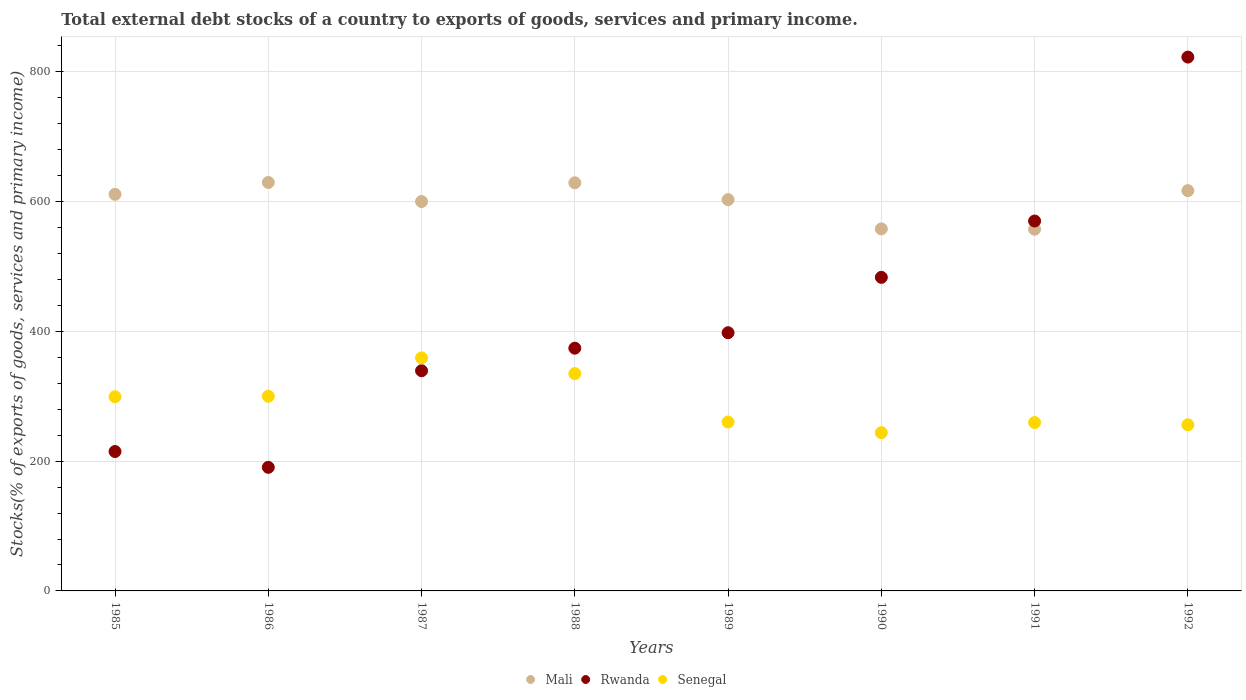How many different coloured dotlines are there?
Give a very brief answer. 3. Is the number of dotlines equal to the number of legend labels?
Provide a short and direct response. Yes. What is the total debt stocks in Senegal in 1985?
Your answer should be very brief. 299.27. Across all years, what is the maximum total debt stocks in Rwanda?
Your answer should be very brief. 822.66. Across all years, what is the minimum total debt stocks in Rwanda?
Ensure brevity in your answer.  190.46. In which year was the total debt stocks in Rwanda maximum?
Your answer should be very brief. 1992. What is the total total debt stocks in Rwanda in the graph?
Provide a short and direct response. 3392.5. What is the difference between the total debt stocks in Mali in 1985 and that in 1988?
Make the answer very short. -17.75. What is the difference between the total debt stocks in Rwanda in 1988 and the total debt stocks in Senegal in 1987?
Your answer should be compact. 14.99. What is the average total debt stocks in Rwanda per year?
Keep it short and to the point. 424.06. In the year 1985, what is the difference between the total debt stocks in Rwanda and total debt stocks in Senegal?
Ensure brevity in your answer.  -84.44. In how many years, is the total debt stocks in Mali greater than 240 %?
Make the answer very short. 8. What is the ratio of the total debt stocks in Rwanda in 1988 to that in 1990?
Your response must be concise. 0.77. Is the total debt stocks in Senegal in 1990 less than that in 1992?
Ensure brevity in your answer.  Yes. Is the difference between the total debt stocks in Rwanda in 1986 and 1987 greater than the difference between the total debt stocks in Senegal in 1986 and 1987?
Your response must be concise. No. What is the difference between the highest and the second highest total debt stocks in Senegal?
Your response must be concise. 24.15. What is the difference between the highest and the lowest total debt stocks in Rwanda?
Make the answer very short. 632.2. Is the sum of the total debt stocks in Senegal in 1990 and 1992 greater than the maximum total debt stocks in Rwanda across all years?
Offer a terse response. No. How many dotlines are there?
Your response must be concise. 3. What is the difference between two consecutive major ticks on the Y-axis?
Your answer should be compact. 200. Are the values on the major ticks of Y-axis written in scientific E-notation?
Your response must be concise. No. Does the graph contain any zero values?
Your answer should be very brief. No. Where does the legend appear in the graph?
Ensure brevity in your answer.  Bottom center. What is the title of the graph?
Offer a very short reply. Total external debt stocks of a country to exports of goods, services and primary income. What is the label or title of the Y-axis?
Your answer should be very brief. Stocks(% of exports of goods, services and primary income). What is the Stocks(% of exports of goods, services and primary income) of Mali in 1985?
Keep it short and to the point. 611.16. What is the Stocks(% of exports of goods, services and primary income) of Rwanda in 1985?
Your response must be concise. 214.83. What is the Stocks(% of exports of goods, services and primary income) in Senegal in 1985?
Your response must be concise. 299.27. What is the Stocks(% of exports of goods, services and primary income) of Mali in 1986?
Your response must be concise. 629.46. What is the Stocks(% of exports of goods, services and primary income) in Rwanda in 1986?
Your response must be concise. 190.46. What is the Stocks(% of exports of goods, services and primary income) in Senegal in 1986?
Provide a succinct answer. 300.03. What is the Stocks(% of exports of goods, services and primary income) of Mali in 1987?
Ensure brevity in your answer.  600.04. What is the Stocks(% of exports of goods, services and primary income) of Rwanda in 1987?
Your response must be concise. 339.33. What is the Stocks(% of exports of goods, services and primary income) in Senegal in 1987?
Offer a terse response. 359.08. What is the Stocks(% of exports of goods, services and primary income) in Mali in 1988?
Provide a short and direct response. 628.91. What is the Stocks(% of exports of goods, services and primary income) in Rwanda in 1988?
Offer a terse response. 374.06. What is the Stocks(% of exports of goods, services and primary income) of Senegal in 1988?
Provide a succinct answer. 334.92. What is the Stocks(% of exports of goods, services and primary income) of Mali in 1989?
Provide a succinct answer. 602.96. What is the Stocks(% of exports of goods, services and primary income) in Rwanda in 1989?
Give a very brief answer. 397.87. What is the Stocks(% of exports of goods, services and primary income) of Senegal in 1989?
Keep it short and to the point. 260.28. What is the Stocks(% of exports of goods, services and primary income) of Mali in 1990?
Offer a terse response. 557.91. What is the Stocks(% of exports of goods, services and primary income) of Rwanda in 1990?
Your answer should be compact. 483.25. What is the Stocks(% of exports of goods, services and primary income) in Senegal in 1990?
Your response must be concise. 243.89. What is the Stocks(% of exports of goods, services and primary income) in Mali in 1991?
Your response must be concise. 557.41. What is the Stocks(% of exports of goods, services and primary income) of Rwanda in 1991?
Keep it short and to the point. 570.04. What is the Stocks(% of exports of goods, services and primary income) in Senegal in 1991?
Your answer should be very brief. 259.49. What is the Stocks(% of exports of goods, services and primary income) in Mali in 1992?
Your response must be concise. 616.85. What is the Stocks(% of exports of goods, services and primary income) in Rwanda in 1992?
Ensure brevity in your answer.  822.66. What is the Stocks(% of exports of goods, services and primary income) of Senegal in 1992?
Your response must be concise. 255.99. Across all years, what is the maximum Stocks(% of exports of goods, services and primary income) in Mali?
Offer a terse response. 629.46. Across all years, what is the maximum Stocks(% of exports of goods, services and primary income) of Rwanda?
Keep it short and to the point. 822.66. Across all years, what is the maximum Stocks(% of exports of goods, services and primary income) of Senegal?
Give a very brief answer. 359.08. Across all years, what is the minimum Stocks(% of exports of goods, services and primary income) of Mali?
Give a very brief answer. 557.41. Across all years, what is the minimum Stocks(% of exports of goods, services and primary income) in Rwanda?
Provide a short and direct response. 190.46. Across all years, what is the minimum Stocks(% of exports of goods, services and primary income) in Senegal?
Make the answer very short. 243.89. What is the total Stocks(% of exports of goods, services and primary income) in Mali in the graph?
Ensure brevity in your answer.  4804.71. What is the total Stocks(% of exports of goods, services and primary income) in Rwanda in the graph?
Your answer should be compact. 3392.5. What is the total Stocks(% of exports of goods, services and primary income) in Senegal in the graph?
Provide a short and direct response. 2312.96. What is the difference between the Stocks(% of exports of goods, services and primary income) of Mali in 1985 and that in 1986?
Your answer should be very brief. -18.29. What is the difference between the Stocks(% of exports of goods, services and primary income) in Rwanda in 1985 and that in 1986?
Keep it short and to the point. 24.36. What is the difference between the Stocks(% of exports of goods, services and primary income) of Senegal in 1985 and that in 1986?
Provide a short and direct response. -0.76. What is the difference between the Stocks(% of exports of goods, services and primary income) in Mali in 1985 and that in 1987?
Give a very brief answer. 11.12. What is the difference between the Stocks(% of exports of goods, services and primary income) of Rwanda in 1985 and that in 1987?
Ensure brevity in your answer.  -124.5. What is the difference between the Stocks(% of exports of goods, services and primary income) in Senegal in 1985 and that in 1987?
Your answer should be compact. -59.8. What is the difference between the Stocks(% of exports of goods, services and primary income) of Mali in 1985 and that in 1988?
Offer a very short reply. -17.75. What is the difference between the Stocks(% of exports of goods, services and primary income) of Rwanda in 1985 and that in 1988?
Your response must be concise. -159.24. What is the difference between the Stocks(% of exports of goods, services and primary income) in Senegal in 1985 and that in 1988?
Provide a short and direct response. -35.65. What is the difference between the Stocks(% of exports of goods, services and primary income) in Mali in 1985 and that in 1989?
Make the answer very short. 8.2. What is the difference between the Stocks(% of exports of goods, services and primary income) of Rwanda in 1985 and that in 1989?
Your answer should be compact. -183.04. What is the difference between the Stocks(% of exports of goods, services and primary income) of Senegal in 1985 and that in 1989?
Provide a short and direct response. 38.99. What is the difference between the Stocks(% of exports of goods, services and primary income) of Mali in 1985 and that in 1990?
Offer a very short reply. 53.25. What is the difference between the Stocks(% of exports of goods, services and primary income) of Rwanda in 1985 and that in 1990?
Your response must be concise. -268.42. What is the difference between the Stocks(% of exports of goods, services and primary income) of Senegal in 1985 and that in 1990?
Keep it short and to the point. 55.38. What is the difference between the Stocks(% of exports of goods, services and primary income) in Mali in 1985 and that in 1991?
Your response must be concise. 53.75. What is the difference between the Stocks(% of exports of goods, services and primary income) in Rwanda in 1985 and that in 1991?
Your answer should be very brief. -355.21. What is the difference between the Stocks(% of exports of goods, services and primary income) in Senegal in 1985 and that in 1991?
Offer a very short reply. 39.78. What is the difference between the Stocks(% of exports of goods, services and primary income) in Mali in 1985 and that in 1992?
Keep it short and to the point. -5.69. What is the difference between the Stocks(% of exports of goods, services and primary income) in Rwanda in 1985 and that in 1992?
Ensure brevity in your answer.  -607.83. What is the difference between the Stocks(% of exports of goods, services and primary income) of Senegal in 1985 and that in 1992?
Your response must be concise. 43.28. What is the difference between the Stocks(% of exports of goods, services and primary income) in Mali in 1986 and that in 1987?
Make the answer very short. 29.41. What is the difference between the Stocks(% of exports of goods, services and primary income) in Rwanda in 1986 and that in 1987?
Your answer should be very brief. -148.86. What is the difference between the Stocks(% of exports of goods, services and primary income) in Senegal in 1986 and that in 1987?
Your response must be concise. -59.05. What is the difference between the Stocks(% of exports of goods, services and primary income) in Mali in 1986 and that in 1988?
Ensure brevity in your answer.  0.55. What is the difference between the Stocks(% of exports of goods, services and primary income) in Rwanda in 1986 and that in 1988?
Keep it short and to the point. -183.6. What is the difference between the Stocks(% of exports of goods, services and primary income) in Senegal in 1986 and that in 1988?
Provide a short and direct response. -34.89. What is the difference between the Stocks(% of exports of goods, services and primary income) in Mali in 1986 and that in 1989?
Ensure brevity in your answer.  26.49. What is the difference between the Stocks(% of exports of goods, services and primary income) in Rwanda in 1986 and that in 1989?
Give a very brief answer. -207.41. What is the difference between the Stocks(% of exports of goods, services and primary income) in Senegal in 1986 and that in 1989?
Provide a short and direct response. 39.75. What is the difference between the Stocks(% of exports of goods, services and primary income) of Mali in 1986 and that in 1990?
Your answer should be very brief. 71.54. What is the difference between the Stocks(% of exports of goods, services and primary income) in Rwanda in 1986 and that in 1990?
Offer a very short reply. -292.78. What is the difference between the Stocks(% of exports of goods, services and primary income) in Senegal in 1986 and that in 1990?
Your answer should be compact. 56.14. What is the difference between the Stocks(% of exports of goods, services and primary income) in Mali in 1986 and that in 1991?
Your response must be concise. 72.05. What is the difference between the Stocks(% of exports of goods, services and primary income) in Rwanda in 1986 and that in 1991?
Ensure brevity in your answer.  -379.58. What is the difference between the Stocks(% of exports of goods, services and primary income) of Senegal in 1986 and that in 1991?
Offer a terse response. 40.53. What is the difference between the Stocks(% of exports of goods, services and primary income) in Mali in 1986 and that in 1992?
Offer a terse response. 12.61. What is the difference between the Stocks(% of exports of goods, services and primary income) of Rwanda in 1986 and that in 1992?
Keep it short and to the point. -632.2. What is the difference between the Stocks(% of exports of goods, services and primary income) in Senegal in 1986 and that in 1992?
Offer a terse response. 44.04. What is the difference between the Stocks(% of exports of goods, services and primary income) of Mali in 1987 and that in 1988?
Ensure brevity in your answer.  -28.87. What is the difference between the Stocks(% of exports of goods, services and primary income) in Rwanda in 1987 and that in 1988?
Your answer should be compact. -34.74. What is the difference between the Stocks(% of exports of goods, services and primary income) in Senegal in 1987 and that in 1988?
Give a very brief answer. 24.15. What is the difference between the Stocks(% of exports of goods, services and primary income) in Mali in 1987 and that in 1989?
Provide a succinct answer. -2.92. What is the difference between the Stocks(% of exports of goods, services and primary income) of Rwanda in 1987 and that in 1989?
Keep it short and to the point. -58.55. What is the difference between the Stocks(% of exports of goods, services and primary income) in Senegal in 1987 and that in 1989?
Give a very brief answer. 98.79. What is the difference between the Stocks(% of exports of goods, services and primary income) of Mali in 1987 and that in 1990?
Provide a short and direct response. 42.13. What is the difference between the Stocks(% of exports of goods, services and primary income) in Rwanda in 1987 and that in 1990?
Make the answer very short. -143.92. What is the difference between the Stocks(% of exports of goods, services and primary income) of Senegal in 1987 and that in 1990?
Offer a terse response. 115.18. What is the difference between the Stocks(% of exports of goods, services and primary income) in Mali in 1987 and that in 1991?
Your answer should be compact. 42.63. What is the difference between the Stocks(% of exports of goods, services and primary income) in Rwanda in 1987 and that in 1991?
Make the answer very short. -230.72. What is the difference between the Stocks(% of exports of goods, services and primary income) of Senegal in 1987 and that in 1991?
Your response must be concise. 99.58. What is the difference between the Stocks(% of exports of goods, services and primary income) in Mali in 1987 and that in 1992?
Provide a short and direct response. -16.81. What is the difference between the Stocks(% of exports of goods, services and primary income) in Rwanda in 1987 and that in 1992?
Your answer should be compact. -483.33. What is the difference between the Stocks(% of exports of goods, services and primary income) of Senegal in 1987 and that in 1992?
Keep it short and to the point. 103.08. What is the difference between the Stocks(% of exports of goods, services and primary income) in Mali in 1988 and that in 1989?
Ensure brevity in your answer.  25.95. What is the difference between the Stocks(% of exports of goods, services and primary income) in Rwanda in 1988 and that in 1989?
Your answer should be very brief. -23.81. What is the difference between the Stocks(% of exports of goods, services and primary income) of Senegal in 1988 and that in 1989?
Your response must be concise. 74.64. What is the difference between the Stocks(% of exports of goods, services and primary income) of Mali in 1988 and that in 1990?
Provide a succinct answer. 71. What is the difference between the Stocks(% of exports of goods, services and primary income) of Rwanda in 1988 and that in 1990?
Provide a short and direct response. -109.18. What is the difference between the Stocks(% of exports of goods, services and primary income) of Senegal in 1988 and that in 1990?
Offer a terse response. 91.03. What is the difference between the Stocks(% of exports of goods, services and primary income) of Mali in 1988 and that in 1991?
Keep it short and to the point. 71.5. What is the difference between the Stocks(% of exports of goods, services and primary income) in Rwanda in 1988 and that in 1991?
Your answer should be compact. -195.98. What is the difference between the Stocks(% of exports of goods, services and primary income) of Senegal in 1988 and that in 1991?
Ensure brevity in your answer.  75.43. What is the difference between the Stocks(% of exports of goods, services and primary income) of Mali in 1988 and that in 1992?
Provide a short and direct response. 12.06. What is the difference between the Stocks(% of exports of goods, services and primary income) of Rwanda in 1988 and that in 1992?
Make the answer very short. -448.6. What is the difference between the Stocks(% of exports of goods, services and primary income) of Senegal in 1988 and that in 1992?
Your answer should be very brief. 78.93. What is the difference between the Stocks(% of exports of goods, services and primary income) of Mali in 1989 and that in 1990?
Your answer should be compact. 45.05. What is the difference between the Stocks(% of exports of goods, services and primary income) of Rwanda in 1989 and that in 1990?
Your answer should be compact. -85.38. What is the difference between the Stocks(% of exports of goods, services and primary income) of Senegal in 1989 and that in 1990?
Provide a short and direct response. 16.39. What is the difference between the Stocks(% of exports of goods, services and primary income) of Mali in 1989 and that in 1991?
Ensure brevity in your answer.  45.55. What is the difference between the Stocks(% of exports of goods, services and primary income) of Rwanda in 1989 and that in 1991?
Keep it short and to the point. -172.17. What is the difference between the Stocks(% of exports of goods, services and primary income) in Senegal in 1989 and that in 1991?
Your answer should be very brief. 0.79. What is the difference between the Stocks(% of exports of goods, services and primary income) in Mali in 1989 and that in 1992?
Provide a short and direct response. -13.88. What is the difference between the Stocks(% of exports of goods, services and primary income) of Rwanda in 1989 and that in 1992?
Your answer should be compact. -424.79. What is the difference between the Stocks(% of exports of goods, services and primary income) in Senegal in 1989 and that in 1992?
Your answer should be very brief. 4.29. What is the difference between the Stocks(% of exports of goods, services and primary income) in Mali in 1990 and that in 1991?
Provide a short and direct response. 0.5. What is the difference between the Stocks(% of exports of goods, services and primary income) in Rwanda in 1990 and that in 1991?
Give a very brief answer. -86.79. What is the difference between the Stocks(% of exports of goods, services and primary income) of Senegal in 1990 and that in 1991?
Your response must be concise. -15.6. What is the difference between the Stocks(% of exports of goods, services and primary income) of Mali in 1990 and that in 1992?
Your answer should be very brief. -58.94. What is the difference between the Stocks(% of exports of goods, services and primary income) in Rwanda in 1990 and that in 1992?
Provide a short and direct response. -339.41. What is the difference between the Stocks(% of exports of goods, services and primary income) in Senegal in 1990 and that in 1992?
Your answer should be compact. -12.1. What is the difference between the Stocks(% of exports of goods, services and primary income) in Mali in 1991 and that in 1992?
Give a very brief answer. -59.44. What is the difference between the Stocks(% of exports of goods, services and primary income) of Rwanda in 1991 and that in 1992?
Make the answer very short. -252.62. What is the difference between the Stocks(% of exports of goods, services and primary income) of Senegal in 1991 and that in 1992?
Keep it short and to the point. 3.5. What is the difference between the Stocks(% of exports of goods, services and primary income) of Mali in 1985 and the Stocks(% of exports of goods, services and primary income) of Rwanda in 1986?
Your answer should be compact. 420.7. What is the difference between the Stocks(% of exports of goods, services and primary income) of Mali in 1985 and the Stocks(% of exports of goods, services and primary income) of Senegal in 1986?
Offer a very short reply. 311.13. What is the difference between the Stocks(% of exports of goods, services and primary income) in Rwanda in 1985 and the Stocks(% of exports of goods, services and primary income) in Senegal in 1986?
Make the answer very short. -85.2. What is the difference between the Stocks(% of exports of goods, services and primary income) of Mali in 1985 and the Stocks(% of exports of goods, services and primary income) of Rwanda in 1987?
Your answer should be very brief. 271.84. What is the difference between the Stocks(% of exports of goods, services and primary income) in Mali in 1985 and the Stocks(% of exports of goods, services and primary income) in Senegal in 1987?
Ensure brevity in your answer.  252.09. What is the difference between the Stocks(% of exports of goods, services and primary income) of Rwanda in 1985 and the Stocks(% of exports of goods, services and primary income) of Senegal in 1987?
Your response must be concise. -144.25. What is the difference between the Stocks(% of exports of goods, services and primary income) of Mali in 1985 and the Stocks(% of exports of goods, services and primary income) of Rwanda in 1988?
Your response must be concise. 237.1. What is the difference between the Stocks(% of exports of goods, services and primary income) in Mali in 1985 and the Stocks(% of exports of goods, services and primary income) in Senegal in 1988?
Keep it short and to the point. 276.24. What is the difference between the Stocks(% of exports of goods, services and primary income) of Rwanda in 1985 and the Stocks(% of exports of goods, services and primary income) of Senegal in 1988?
Make the answer very short. -120.1. What is the difference between the Stocks(% of exports of goods, services and primary income) of Mali in 1985 and the Stocks(% of exports of goods, services and primary income) of Rwanda in 1989?
Provide a short and direct response. 213.29. What is the difference between the Stocks(% of exports of goods, services and primary income) of Mali in 1985 and the Stocks(% of exports of goods, services and primary income) of Senegal in 1989?
Give a very brief answer. 350.88. What is the difference between the Stocks(% of exports of goods, services and primary income) of Rwanda in 1985 and the Stocks(% of exports of goods, services and primary income) of Senegal in 1989?
Your response must be concise. -45.46. What is the difference between the Stocks(% of exports of goods, services and primary income) of Mali in 1985 and the Stocks(% of exports of goods, services and primary income) of Rwanda in 1990?
Keep it short and to the point. 127.92. What is the difference between the Stocks(% of exports of goods, services and primary income) of Mali in 1985 and the Stocks(% of exports of goods, services and primary income) of Senegal in 1990?
Offer a terse response. 367.27. What is the difference between the Stocks(% of exports of goods, services and primary income) in Rwanda in 1985 and the Stocks(% of exports of goods, services and primary income) in Senegal in 1990?
Make the answer very short. -29.07. What is the difference between the Stocks(% of exports of goods, services and primary income) in Mali in 1985 and the Stocks(% of exports of goods, services and primary income) in Rwanda in 1991?
Your answer should be compact. 41.12. What is the difference between the Stocks(% of exports of goods, services and primary income) of Mali in 1985 and the Stocks(% of exports of goods, services and primary income) of Senegal in 1991?
Offer a very short reply. 351.67. What is the difference between the Stocks(% of exports of goods, services and primary income) of Rwanda in 1985 and the Stocks(% of exports of goods, services and primary income) of Senegal in 1991?
Provide a succinct answer. -44.67. What is the difference between the Stocks(% of exports of goods, services and primary income) of Mali in 1985 and the Stocks(% of exports of goods, services and primary income) of Rwanda in 1992?
Provide a succinct answer. -211.5. What is the difference between the Stocks(% of exports of goods, services and primary income) of Mali in 1985 and the Stocks(% of exports of goods, services and primary income) of Senegal in 1992?
Your response must be concise. 355.17. What is the difference between the Stocks(% of exports of goods, services and primary income) in Rwanda in 1985 and the Stocks(% of exports of goods, services and primary income) in Senegal in 1992?
Give a very brief answer. -41.17. What is the difference between the Stocks(% of exports of goods, services and primary income) of Mali in 1986 and the Stocks(% of exports of goods, services and primary income) of Rwanda in 1987?
Provide a succinct answer. 290.13. What is the difference between the Stocks(% of exports of goods, services and primary income) in Mali in 1986 and the Stocks(% of exports of goods, services and primary income) in Senegal in 1987?
Provide a succinct answer. 270.38. What is the difference between the Stocks(% of exports of goods, services and primary income) of Rwanda in 1986 and the Stocks(% of exports of goods, services and primary income) of Senegal in 1987?
Give a very brief answer. -168.61. What is the difference between the Stocks(% of exports of goods, services and primary income) in Mali in 1986 and the Stocks(% of exports of goods, services and primary income) in Rwanda in 1988?
Keep it short and to the point. 255.39. What is the difference between the Stocks(% of exports of goods, services and primary income) of Mali in 1986 and the Stocks(% of exports of goods, services and primary income) of Senegal in 1988?
Your answer should be very brief. 294.53. What is the difference between the Stocks(% of exports of goods, services and primary income) in Rwanda in 1986 and the Stocks(% of exports of goods, services and primary income) in Senegal in 1988?
Provide a succinct answer. -144.46. What is the difference between the Stocks(% of exports of goods, services and primary income) of Mali in 1986 and the Stocks(% of exports of goods, services and primary income) of Rwanda in 1989?
Provide a succinct answer. 231.59. What is the difference between the Stocks(% of exports of goods, services and primary income) of Mali in 1986 and the Stocks(% of exports of goods, services and primary income) of Senegal in 1989?
Provide a succinct answer. 369.17. What is the difference between the Stocks(% of exports of goods, services and primary income) of Rwanda in 1986 and the Stocks(% of exports of goods, services and primary income) of Senegal in 1989?
Provide a short and direct response. -69.82. What is the difference between the Stocks(% of exports of goods, services and primary income) in Mali in 1986 and the Stocks(% of exports of goods, services and primary income) in Rwanda in 1990?
Your response must be concise. 146.21. What is the difference between the Stocks(% of exports of goods, services and primary income) of Mali in 1986 and the Stocks(% of exports of goods, services and primary income) of Senegal in 1990?
Keep it short and to the point. 385.56. What is the difference between the Stocks(% of exports of goods, services and primary income) in Rwanda in 1986 and the Stocks(% of exports of goods, services and primary income) in Senegal in 1990?
Make the answer very short. -53.43. What is the difference between the Stocks(% of exports of goods, services and primary income) of Mali in 1986 and the Stocks(% of exports of goods, services and primary income) of Rwanda in 1991?
Provide a short and direct response. 59.42. What is the difference between the Stocks(% of exports of goods, services and primary income) of Mali in 1986 and the Stocks(% of exports of goods, services and primary income) of Senegal in 1991?
Keep it short and to the point. 369.96. What is the difference between the Stocks(% of exports of goods, services and primary income) in Rwanda in 1986 and the Stocks(% of exports of goods, services and primary income) in Senegal in 1991?
Keep it short and to the point. -69.03. What is the difference between the Stocks(% of exports of goods, services and primary income) in Mali in 1986 and the Stocks(% of exports of goods, services and primary income) in Rwanda in 1992?
Offer a terse response. -193.2. What is the difference between the Stocks(% of exports of goods, services and primary income) in Mali in 1986 and the Stocks(% of exports of goods, services and primary income) in Senegal in 1992?
Your response must be concise. 373.46. What is the difference between the Stocks(% of exports of goods, services and primary income) in Rwanda in 1986 and the Stocks(% of exports of goods, services and primary income) in Senegal in 1992?
Provide a succinct answer. -65.53. What is the difference between the Stocks(% of exports of goods, services and primary income) in Mali in 1987 and the Stocks(% of exports of goods, services and primary income) in Rwanda in 1988?
Offer a very short reply. 225.98. What is the difference between the Stocks(% of exports of goods, services and primary income) in Mali in 1987 and the Stocks(% of exports of goods, services and primary income) in Senegal in 1988?
Keep it short and to the point. 265.12. What is the difference between the Stocks(% of exports of goods, services and primary income) of Rwanda in 1987 and the Stocks(% of exports of goods, services and primary income) of Senegal in 1988?
Ensure brevity in your answer.  4.4. What is the difference between the Stocks(% of exports of goods, services and primary income) of Mali in 1987 and the Stocks(% of exports of goods, services and primary income) of Rwanda in 1989?
Offer a very short reply. 202.17. What is the difference between the Stocks(% of exports of goods, services and primary income) of Mali in 1987 and the Stocks(% of exports of goods, services and primary income) of Senegal in 1989?
Give a very brief answer. 339.76. What is the difference between the Stocks(% of exports of goods, services and primary income) in Rwanda in 1987 and the Stocks(% of exports of goods, services and primary income) in Senegal in 1989?
Provide a short and direct response. 79.04. What is the difference between the Stocks(% of exports of goods, services and primary income) in Mali in 1987 and the Stocks(% of exports of goods, services and primary income) in Rwanda in 1990?
Your response must be concise. 116.8. What is the difference between the Stocks(% of exports of goods, services and primary income) of Mali in 1987 and the Stocks(% of exports of goods, services and primary income) of Senegal in 1990?
Give a very brief answer. 356.15. What is the difference between the Stocks(% of exports of goods, services and primary income) in Rwanda in 1987 and the Stocks(% of exports of goods, services and primary income) in Senegal in 1990?
Your answer should be compact. 95.43. What is the difference between the Stocks(% of exports of goods, services and primary income) of Mali in 1987 and the Stocks(% of exports of goods, services and primary income) of Rwanda in 1991?
Provide a short and direct response. 30. What is the difference between the Stocks(% of exports of goods, services and primary income) in Mali in 1987 and the Stocks(% of exports of goods, services and primary income) in Senegal in 1991?
Your answer should be compact. 340.55. What is the difference between the Stocks(% of exports of goods, services and primary income) of Rwanda in 1987 and the Stocks(% of exports of goods, services and primary income) of Senegal in 1991?
Your response must be concise. 79.83. What is the difference between the Stocks(% of exports of goods, services and primary income) of Mali in 1987 and the Stocks(% of exports of goods, services and primary income) of Rwanda in 1992?
Provide a succinct answer. -222.62. What is the difference between the Stocks(% of exports of goods, services and primary income) of Mali in 1987 and the Stocks(% of exports of goods, services and primary income) of Senegal in 1992?
Offer a terse response. 344.05. What is the difference between the Stocks(% of exports of goods, services and primary income) in Rwanda in 1987 and the Stocks(% of exports of goods, services and primary income) in Senegal in 1992?
Provide a succinct answer. 83.33. What is the difference between the Stocks(% of exports of goods, services and primary income) of Mali in 1988 and the Stocks(% of exports of goods, services and primary income) of Rwanda in 1989?
Your response must be concise. 231.04. What is the difference between the Stocks(% of exports of goods, services and primary income) in Mali in 1988 and the Stocks(% of exports of goods, services and primary income) in Senegal in 1989?
Give a very brief answer. 368.63. What is the difference between the Stocks(% of exports of goods, services and primary income) in Rwanda in 1988 and the Stocks(% of exports of goods, services and primary income) in Senegal in 1989?
Your answer should be very brief. 113.78. What is the difference between the Stocks(% of exports of goods, services and primary income) of Mali in 1988 and the Stocks(% of exports of goods, services and primary income) of Rwanda in 1990?
Your answer should be compact. 145.66. What is the difference between the Stocks(% of exports of goods, services and primary income) in Mali in 1988 and the Stocks(% of exports of goods, services and primary income) in Senegal in 1990?
Offer a terse response. 385.02. What is the difference between the Stocks(% of exports of goods, services and primary income) of Rwanda in 1988 and the Stocks(% of exports of goods, services and primary income) of Senegal in 1990?
Provide a succinct answer. 130.17. What is the difference between the Stocks(% of exports of goods, services and primary income) of Mali in 1988 and the Stocks(% of exports of goods, services and primary income) of Rwanda in 1991?
Provide a succinct answer. 58.87. What is the difference between the Stocks(% of exports of goods, services and primary income) of Mali in 1988 and the Stocks(% of exports of goods, services and primary income) of Senegal in 1991?
Your response must be concise. 369.42. What is the difference between the Stocks(% of exports of goods, services and primary income) of Rwanda in 1988 and the Stocks(% of exports of goods, services and primary income) of Senegal in 1991?
Your response must be concise. 114.57. What is the difference between the Stocks(% of exports of goods, services and primary income) in Mali in 1988 and the Stocks(% of exports of goods, services and primary income) in Rwanda in 1992?
Offer a terse response. -193.75. What is the difference between the Stocks(% of exports of goods, services and primary income) in Mali in 1988 and the Stocks(% of exports of goods, services and primary income) in Senegal in 1992?
Your answer should be compact. 372.92. What is the difference between the Stocks(% of exports of goods, services and primary income) in Rwanda in 1988 and the Stocks(% of exports of goods, services and primary income) in Senegal in 1992?
Offer a very short reply. 118.07. What is the difference between the Stocks(% of exports of goods, services and primary income) of Mali in 1989 and the Stocks(% of exports of goods, services and primary income) of Rwanda in 1990?
Your answer should be compact. 119.72. What is the difference between the Stocks(% of exports of goods, services and primary income) of Mali in 1989 and the Stocks(% of exports of goods, services and primary income) of Senegal in 1990?
Ensure brevity in your answer.  359.07. What is the difference between the Stocks(% of exports of goods, services and primary income) in Rwanda in 1989 and the Stocks(% of exports of goods, services and primary income) in Senegal in 1990?
Make the answer very short. 153.98. What is the difference between the Stocks(% of exports of goods, services and primary income) of Mali in 1989 and the Stocks(% of exports of goods, services and primary income) of Rwanda in 1991?
Your answer should be compact. 32.92. What is the difference between the Stocks(% of exports of goods, services and primary income) of Mali in 1989 and the Stocks(% of exports of goods, services and primary income) of Senegal in 1991?
Your answer should be compact. 343.47. What is the difference between the Stocks(% of exports of goods, services and primary income) of Rwanda in 1989 and the Stocks(% of exports of goods, services and primary income) of Senegal in 1991?
Your answer should be compact. 138.38. What is the difference between the Stocks(% of exports of goods, services and primary income) of Mali in 1989 and the Stocks(% of exports of goods, services and primary income) of Rwanda in 1992?
Keep it short and to the point. -219.7. What is the difference between the Stocks(% of exports of goods, services and primary income) in Mali in 1989 and the Stocks(% of exports of goods, services and primary income) in Senegal in 1992?
Offer a very short reply. 346.97. What is the difference between the Stocks(% of exports of goods, services and primary income) in Rwanda in 1989 and the Stocks(% of exports of goods, services and primary income) in Senegal in 1992?
Keep it short and to the point. 141.88. What is the difference between the Stocks(% of exports of goods, services and primary income) in Mali in 1990 and the Stocks(% of exports of goods, services and primary income) in Rwanda in 1991?
Your answer should be very brief. -12.13. What is the difference between the Stocks(% of exports of goods, services and primary income) in Mali in 1990 and the Stocks(% of exports of goods, services and primary income) in Senegal in 1991?
Your response must be concise. 298.42. What is the difference between the Stocks(% of exports of goods, services and primary income) in Rwanda in 1990 and the Stocks(% of exports of goods, services and primary income) in Senegal in 1991?
Give a very brief answer. 223.75. What is the difference between the Stocks(% of exports of goods, services and primary income) of Mali in 1990 and the Stocks(% of exports of goods, services and primary income) of Rwanda in 1992?
Make the answer very short. -264.75. What is the difference between the Stocks(% of exports of goods, services and primary income) in Mali in 1990 and the Stocks(% of exports of goods, services and primary income) in Senegal in 1992?
Make the answer very short. 301.92. What is the difference between the Stocks(% of exports of goods, services and primary income) of Rwanda in 1990 and the Stocks(% of exports of goods, services and primary income) of Senegal in 1992?
Make the answer very short. 227.25. What is the difference between the Stocks(% of exports of goods, services and primary income) in Mali in 1991 and the Stocks(% of exports of goods, services and primary income) in Rwanda in 1992?
Provide a short and direct response. -265.25. What is the difference between the Stocks(% of exports of goods, services and primary income) in Mali in 1991 and the Stocks(% of exports of goods, services and primary income) in Senegal in 1992?
Give a very brief answer. 301.42. What is the difference between the Stocks(% of exports of goods, services and primary income) in Rwanda in 1991 and the Stocks(% of exports of goods, services and primary income) in Senegal in 1992?
Your answer should be compact. 314.05. What is the average Stocks(% of exports of goods, services and primary income) in Mali per year?
Provide a succinct answer. 600.59. What is the average Stocks(% of exports of goods, services and primary income) in Rwanda per year?
Provide a succinct answer. 424.06. What is the average Stocks(% of exports of goods, services and primary income) in Senegal per year?
Give a very brief answer. 289.12. In the year 1985, what is the difference between the Stocks(% of exports of goods, services and primary income) of Mali and Stocks(% of exports of goods, services and primary income) of Rwanda?
Provide a short and direct response. 396.34. In the year 1985, what is the difference between the Stocks(% of exports of goods, services and primary income) in Mali and Stocks(% of exports of goods, services and primary income) in Senegal?
Keep it short and to the point. 311.89. In the year 1985, what is the difference between the Stocks(% of exports of goods, services and primary income) in Rwanda and Stocks(% of exports of goods, services and primary income) in Senegal?
Offer a terse response. -84.44. In the year 1986, what is the difference between the Stocks(% of exports of goods, services and primary income) in Mali and Stocks(% of exports of goods, services and primary income) in Rwanda?
Provide a succinct answer. 438.99. In the year 1986, what is the difference between the Stocks(% of exports of goods, services and primary income) of Mali and Stocks(% of exports of goods, services and primary income) of Senegal?
Offer a terse response. 329.43. In the year 1986, what is the difference between the Stocks(% of exports of goods, services and primary income) in Rwanda and Stocks(% of exports of goods, services and primary income) in Senegal?
Provide a short and direct response. -109.57. In the year 1987, what is the difference between the Stocks(% of exports of goods, services and primary income) of Mali and Stocks(% of exports of goods, services and primary income) of Rwanda?
Your response must be concise. 260.72. In the year 1987, what is the difference between the Stocks(% of exports of goods, services and primary income) in Mali and Stocks(% of exports of goods, services and primary income) in Senegal?
Offer a terse response. 240.97. In the year 1987, what is the difference between the Stocks(% of exports of goods, services and primary income) of Rwanda and Stocks(% of exports of goods, services and primary income) of Senegal?
Your answer should be very brief. -19.75. In the year 1988, what is the difference between the Stocks(% of exports of goods, services and primary income) of Mali and Stocks(% of exports of goods, services and primary income) of Rwanda?
Make the answer very short. 254.85. In the year 1988, what is the difference between the Stocks(% of exports of goods, services and primary income) of Mali and Stocks(% of exports of goods, services and primary income) of Senegal?
Give a very brief answer. 293.99. In the year 1988, what is the difference between the Stocks(% of exports of goods, services and primary income) of Rwanda and Stocks(% of exports of goods, services and primary income) of Senegal?
Offer a terse response. 39.14. In the year 1989, what is the difference between the Stocks(% of exports of goods, services and primary income) of Mali and Stocks(% of exports of goods, services and primary income) of Rwanda?
Your answer should be very brief. 205.09. In the year 1989, what is the difference between the Stocks(% of exports of goods, services and primary income) in Mali and Stocks(% of exports of goods, services and primary income) in Senegal?
Offer a terse response. 342.68. In the year 1989, what is the difference between the Stocks(% of exports of goods, services and primary income) in Rwanda and Stocks(% of exports of goods, services and primary income) in Senegal?
Give a very brief answer. 137.59. In the year 1990, what is the difference between the Stocks(% of exports of goods, services and primary income) of Mali and Stocks(% of exports of goods, services and primary income) of Rwanda?
Offer a terse response. 74.67. In the year 1990, what is the difference between the Stocks(% of exports of goods, services and primary income) in Mali and Stocks(% of exports of goods, services and primary income) in Senegal?
Offer a very short reply. 314.02. In the year 1990, what is the difference between the Stocks(% of exports of goods, services and primary income) in Rwanda and Stocks(% of exports of goods, services and primary income) in Senegal?
Offer a terse response. 239.36. In the year 1991, what is the difference between the Stocks(% of exports of goods, services and primary income) of Mali and Stocks(% of exports of goods, services and primary income) of Rwanda?
Provide a succinct answer. -12.63. In the year 1991, what is the difference between the Stocks(% of exports of goods, services and primary income) in Mali and Stocks(% of exports of goods, services and primary income) in Senegal?
Make the answer very short. 297.91. In the year 1991, what is the difference between the Stocks(% of exports of goods, services and primary income) in Rwanda and Stocks(% of exports of goods, services and primary income) in Senegal?
Your answer should be very brief. 310.55. In the year 1992, what is the difference between the Stocks(% of exports of goods, services and primary income) of Mali and Stocks(% of exports of goods, services and primary income) of Rwanda?
Offer a very short reply. -205.81. In the year 1992, what is the difference between the Stocks(% of exports of goods, services and primary income) in Mali and Stocks(% of exports of goods, services and primary income) in Senegal?
Provide a short and direct response. 360.85. In the year 1992, what is the difference between the Stocks(% of exports of goods, services and primary income) in Rwanda and Stocks(% of exports of goods, services and primary income) in Senegal?
Your response must be concise. 566.67. What is the ratio of the Stocks(% of exports of goods, services and primary income) in Mali in 1985 to that in 1986?
Offer a terse response. 0.97. What is the ratio of the Stocks(% of exports of goods, services and primary income) of Rwanda in 1985 to that in 1986?
Your answer should be very brief. 1.13. What is the ratio of the Stocks(% of exports of goods, services and primary income) in Mali in 1985 to that in 1987?
Give a very brief answer. 1.02. What is the ratio of the Stocks(% of exports of goods, services and primary income) in Rwanda in 1985 to that in 1987?
Offer a very short reply. 0.63. What is the ratio of the Stocks(% of exports of goods, services and primary income) of Senegal in 1985 to that in 1987?
Ensure brevity in your answer.  0.83. What is the ratio of the Stocks(% of exports of goods, services and primary income) of Mali in 1985 to that in 1988?
Provide a succinct answer. 0.97. What is the ratio of the Stocks(% of exports of goods, services and primary income) of Rwanda in 1985 to that in 1988?
Make the answer very short. 0.57. What is the ratio of the Stocks(% of exports of goods, services and primary income) of Senegal in 1985 to that in 1988?
Keep it short and to the point. 0.89. What is the ratio of the Stocks(% of exports of goods, services and primary income) of Mali in 1985 to that in 1989?
Offer a terse response. 1.01. What is the ratio of the Stocks(% of exports of goods, services and primary income) of Rwanda in 1985 to that in 1989?
Your answer should be compact. 0.54. What is the ratio of the Stocks(% of exports of goods, services and primary income) of Senegal in 1985 to that in 1989?
Give a very brief answer. 1.15. What is the ratio of the Stocks(% of exports of goods, services and primary income) in Mali in 1985 to that in 1990?
Make the answer very short. 1.1. What is the ratio of the Stocks(% of exports of goods, services and primary income) in Rwanda in 1985 to that in 1990?
Make the answer very short. 0.44. What is the ratio of the Stocks(% of exports of goods, services and primary income) of Senegal in 1985 to that in 1990?
Ensure brevity in your answer.  1.23. What is the ratio of the Stocks(% of exports of goods, services and primary income) in Mali in 1985 to that in 1991?
Offer a very short reply. 1.1. What is the ratio of the Stocks(% of exports of goods, services and primary income) in Rwanda in 1985 to that in 1991?
Offer a terse response. 0.38. What is the ratio of the Stocks(% of exports of goods, services and primary income) in Senegal in 1985 to that in 1991?
Provide a short and direct response. 1.15. What is the ratio of the Stocks(% of exports of goods, services and primary income) in Mali in 1985 to that in 1992?
Your answer should be very brief. 0.99. What is the ratio of the Stocks(% of exports of goods, services and primary income) of Rwanda in 1985 to that in 1992?
Ensure brevity in your answer.  0.26. What is the ratio of the Stocks(% of exports of goods, services and primary income) of Senegal in 1985 to that in 1992?
Offer a terse response. 1.17. What is the ratio of the Stocks(% of exports of goods, services and primary income) of Mali in 1986 to that in 1987?
Your response must be concise. 1.05. What is the ratio of the Stocks(% of exports of goods, services and primary income) of Rwanda in 1986 to that in 1987?
Give a very brief answer. 0.56. What is the ratio of the Stocks(% of exports of goods, services and primary income) in Senegal in 1986 to that in 1987?
Provide a short and direct response. 0.84. What is the ratio of the Stocks(% of exports of goods, services and primary income) in Mali in 1986 to that in 1988?
Your answer should be compact. 1. What is the ratio of the Stocks(% of exports of goods, services and primary income) in Rwanda in 1986 to that in 1988?
Make the answer very short. 0.51. What is the ratio of the Stocks(% of exports of goods, services and primary income) of Senegal in 1986 to that in 1988?
Offer a very short reply. 0.9. What is the ratio of the Stocks(% of exports of goods, services and primary income) in Mali in 1986 to that in 1989?
Provide a short and direct response. 1.04. What is the ratio of the Stocks(% of exports of goods, services and primary income) of Rwanda in 1986 to that in 1989?
Your response must be concise. 0.48. What is the ratio of the Stocks(% of exports of goods, services and primary income) of Senegal in 1986 to that in 1989?
Your answer should be compact. 1.15. What is the ratio of the Stocks(% of exports of goods, services and primary income) in Mali in 1986 to that in 1990?
Your answer should be very brief. 1.13. What is the ratio of the Stocks(% of exports of goods, services and primary income) of Rwanda in 1986 to that in 1990?
Make the answer very short. 0.39. What is the ratio of the Stocks(% of exports of goods, services and primary income) in Senegal in 1986 to that in 1990?
Your answer should be compact. 1.23. What is the ratio of the Stocks(% of exports of goods, services and primary income) in Mali in 1986 to that in 1991?
Your response must be concise. 1.13. What is the ratio of the Stocks(% of exports of goods, services and primary income) of Rwanda in 1986 to that in 1991?
Make the answer very short. 0.33. What is the ratio of the Stocks(% of exports of goods, services and primary income) of Senegal in 1986 to that in 1991?
Offer a very short reply. 1.16. What is the ratio of the Stocks(% of exports of goods, services and primary income) of Mali in 1986 to that in 1992?
Your response must be concise. 1.02. What is the ratio of the Stocks(% of exports of goods, services and primary income) of Rwanda in 1986 to that in 1992?
Your response must be concise. 0.23. What is the ratio of the Stocks(% of exports of goods, services and primary income) of Senegal in 1986 to that in 1992?
Make the answer very short. 1.17. What is the ratio of the Stocks(% of exports of goods, services and primary income) in Mali in 1987 to that in 1988?
Provide a short and direct response. 0.95. What is the ratio of the Stocks(% of exports of goods, services and primary income) of Rwanda in 1987 to that in 1988?
Give a very brief answer. 0.91. What is the ratio of the Stocks(% of exports of goods, services and primary income) in Senegal in 1987 to that in 1988?
Your answer should be compact. 1.07. What is the ratio of the Stocks(% of exports of goods, services and primary income) of Mali in 1987 to that in 1989?
Your response must be concise. 1. What is the ratio of the Stocks(% of exports of goods, services and primary income) of Rwanda in 1987 to that in 1989?
Offer a terse response. 0.85. What is the ratio of the Stocks(% of exports of goods, services and primary income) of Senegal in 1987 to that in 1989?
Keep it short and to the point. 1.38. What is the ratio of the Stocks(% of exports of goods, services and primary income) of Mali in 1987 to that in 1990?
Give a very brief answer. 1.08. What is the ratio of the Stocks(% of exports of goods, services and primary income) of Rwanda in 1987 to that in 1990?
Your answer should be very brief. 0.7. What is the ratio of the Stocks(% of exports of goods, services and primary income) in Senegal in 1987 to that in 1990?
Keep it short and to the point. 1.47. What is the ratio of the Stocks(% of exports of goods, services and primary income) in Mali in 1987 to that in 1991?
Give a very brief answer. 1.08. What is the ratio of the Stocks(% of exports of goods, services and primary income) of Rwanda in 1987 to that in 1991?
Offer a terse response. 0.6. What is the ratio of the Stocks(% of exports of goods, services and primary income) of Senegal in 1987 to that in 1991?
Your answer should be very brief. 1.38. What is the ratio of the Stocks(% of exports of goods, services and primary income) of Mali in 1987 to that in 1992?
Ensure brevity in your answer.  0.97. What is the ratio of the Stocks(% of exports of goods, services and primary income) in Rwanda in 1987 to that in 1992?
Your answer should be very brief. 0.41. What is the ratio of the Stocks(% of exports of goods, services and primary income) of Senegal in 1987 to that in 1992?
Give a very brief answer. 1.4. What is the ratio of the Stocks(% of exports of goods, services and primary income) in Mali in 1988 to that in 1989?
Provide a succinct answer. 1.04. What is the ratio of the Stocks(% of exports of goods, services and primary income) in Rwanda in 1988 to that in 1989?
Make the answer very short. 0.94. What is the ratio of the Stocks(% of exports of goods, services and primary income) of Senegal in 1988 to that in 1989?
Your answer should be very brief. 1.29. What is the ratio of the Stocks(% of exports of goods, services and primary income) in Mali in 1988 to that in 1990?
Your answer should be very brief. 1.13. What is the ratio of the Stocks(% of exports of goods, services and primary income) in Rwanda in 1988 to that in 1990?
Provide a short and direct response. 0.77. What is the ratio of the Stocks(% of exports of goods, services and primary income) of Senegal in 1988 to that in 1990?
Keep it short and to the point. 1.37. What is the ratio of the Stocks(% of exports of goods, services and primary income) of Mali in 1988 to that in 1991?
Offer a very short reply. 1.13. What is the ratio of the Stocks(% of exports of goods, services and primary income) in Rwanda in 1988 to that in 1991?
Provide a short and direct response. 0.66. What is the ratio of the Stocks(% of exports of goods, services and primary income) of Senegal in 1988 to that in 1991?
Offer a very short reply. 1.29. What is the ratio of the Stocks(% of exports of goods, services and primary income) of Mali in 1988 to that in 1992?
Ensure brevity in your answer.  1.02. What is the ratio of the Stocks(% of exports of goods, services and primary income) in Rwanda in 1988 to that in 1992?
Your answer should be compact. 0.45. What is the ratio of the Stocks(% of exports of goods, services and primary income) in Senegal in 1988 to that in 1992?
Make the answer very short. 1.31. What is the ratio of the Stocks(% of exports of goods, services and primary income) of Mali in 1989 to that in 1990?
Ensure brevity in your answer.  1.08. What is the ratio of the Stocks(% of exports of goods, services and primary income) in Rwanda in 1989 to that in 1990?
Your answer should be very brief. 0.82. What is the ratio of the Stocks(% of exports of goods, services and primary income) of Senegal in 1989 to that in 1990?
Offer a terse response. 1.07. What is the ratio of the Stocks(% of exports of goods, services and primary income) in Mali in 1989 to that in 1991?
Your answer should be very brief. 1.08. What is the ratio of the Stocks(% of exports of goods, services and primary income) in Rwanda in 1989 to that in 1991?
Your answer should be very brief. 0.7. What is the ratio of the Stocks(% of exports of goods, services and primary income) of Mali in 1989 to that in 1992?
Make the answer very short. 0.98. What is the ratio of the Stocks(% of exports of goods, services and primary income) of Rwanda in 1989 to that in 1992?
Your response must be concise. 0.48. What is the ratio of the Stocks(% of exports of goods, services and primary income) of Senegal in 1989 to that in 1992?
Your response must be concise. 1.02. What is the ratio of the Stocks(% of exports of goods, services and primary income) in Mali in 1990 to that in 1991?
Provide a succinct answer. 1. What is the ratio of the Stocks(% of exports of goods, services and primary income) of Rwanda in 1990 to that in 1991?
Provide a short and direct response. 0.85. What is the ratio of the Stocks(% of exports of goods, services and primary income) in Senegal in 1990 to that in 1991?
Offer a terse response. 0.94. What is the ratio of the Stocks(% of exports of goods, services and primary income) of Mali in 1990 to that in 1992?
Offer a terse response. 0.9. What is the ratio of the Stocks(% of exports of goods, services and primary income) in Rwanda in 1990 to that in 1992?
Offer a terse response. 0.59. What is the ratio of the Stocks(% of exports of goods, services and primary income) of Senegal in 1990 to that in 1992?
Give a very brief answer. 0.95. What is the ratio of the Stocks(% of exports of goods, services and primary income) of Mali in 1991 to that in 1992?
Provide a succinct answer. 0.9. What is the ratio of the Stocks(% of exports of goods, services and primary income) in Rwanda in 1991 to that in 1992?
Keep it short and to the point. 0.69. What is the ratio of the Stocks(% of exports of goods, services and primary income) of Senegal in 1991 to that in 1992?
Your answer should be very brief. 1.01. What is the difference between the highest and the second highest Stocks(% of exports of goods, services and primary income) in Mali?
Ensure brevity in your answer.  0.55. What is the difference between the highest and the second highest Stocks(% of exports of goods, services and primary income) in Rwanda?
Your answer should be very brief. 252.62. What is the difference between the highest and the second highest Stocks(% of exports of goods, services and primary income) of Senegal?
Provide a short and direct response. 24.15. What is the difference between the highest and the lowest Stocks(% of exports of goods, services and primary income) of Mali?
Your answer should be compact. 72.05. What is the difference between the highest and the lowest Stocks(% of exports of goods, services and primary income) in Rwanda?
Provide a short and direct response. 632.2. What is the difference between the highest and the lowest Stocks(% of exports of goods, services and primary income) of Senegal?
Your response must be concise. 115.18. 